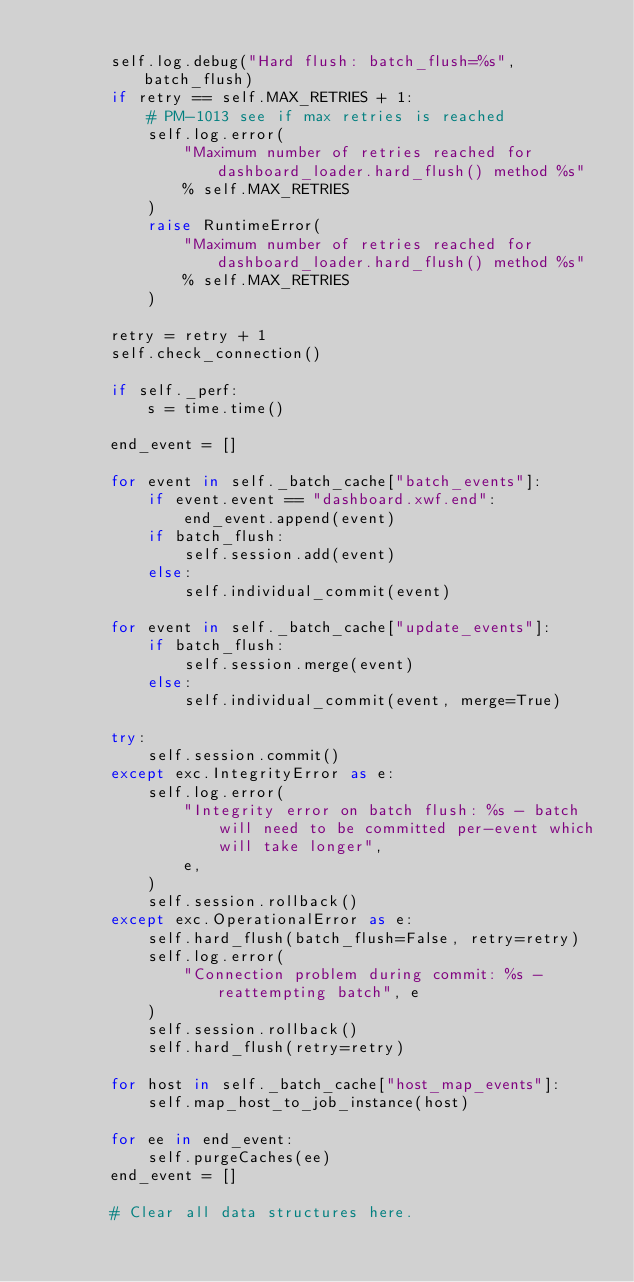<code> <loc_0><loc_0><loc_500><loc_500><_Python_>
        self.log.debug("Hard flush: batch_flush=%s", batch_flush)
        if retry == self.MAX_RETRIES + 1:
            # PM-1013 see if max retries is reached
            self.log.error(
                "Maximum number of retries reached for dashboard_loader.hard_flush() method %s"
                % self.MAX_RETRIES
            )
            raise RuntimeError(
                "Maximum number of retries reached for dashboard_loader.hard_flush() method %s"
                % self.MAX_RETRIES
            )

        retry = retry + 1
        self.check_connection()

        if self._perf:
            s = time.time()

        end_event = []

        for event in self._batch_cache["batch_events"]:
            if event.event == "dashboard.xwf.end":
                end_event.append(event)
            if batch_flush:
                self.session.add(event)
            else:
                self.individual_commit(event)

        for event in self._batch_cache["update_events"]:
            if batch_flush:
                self.session.merge(event)
            else:
                self.individual_commit(event, merge=True)

        try:
            self.session.commit()
        except exc.IntegrityError as e:
            self.log.error(
                "Integrity error on batch flush: %s - batch will need to be committed per-event which will take longer",
                e,
            )
            self.session.rollback()
        except exc.OperationalError as e:
            self.hard_flush(batch_flush=False, retry=retry)
            self.log.error(
                "Connection problem during commit: %s - reattempting batch", e
            )
            self.session.rollback()
            self.hard_flush(retry=retry)

        for host in self._batch_cache["host_map_events"]:
            self.map_host_to_job_instance(host)

        for ee in end_event:
            self.purgeCaches(ee)
        end_event = []

        # Clear all data structures here.</code> 